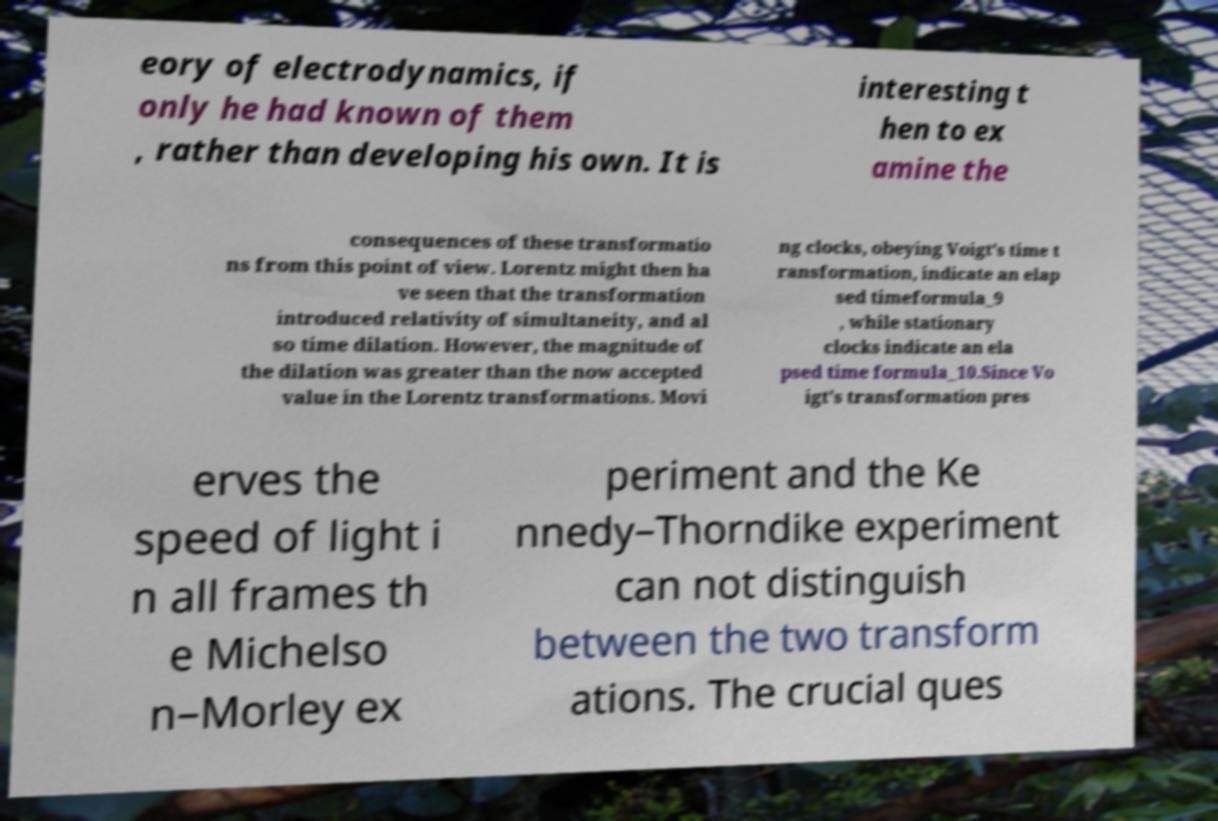Please read and relay the text visible in this image. What does it say? eory of electrodynamics, if only he had known of them , rather than developing his own. It is interesting t hen to ex amine the consequences of these transformatio ns from this point of view. Lorentz might then ha ve seen that the transformation introduced relativity of simultaneity, and al so time dilation. However, the magnitude of the dilation was greater than the now accepted value in the Lorentz transformations. Movi ng clocks, obeying Voigt's time t ransformation, indicate an elap sed timeformula_9 , while stationary clocks indicate an ela psed time formula_10.Since Vo igt's transformation pres erves the speed of light i n all frames th e Michelso n–Morley ex periment and the Ke nnedy–Thorndike experiment can not distinguish between the two transform ations. The crucial ques 